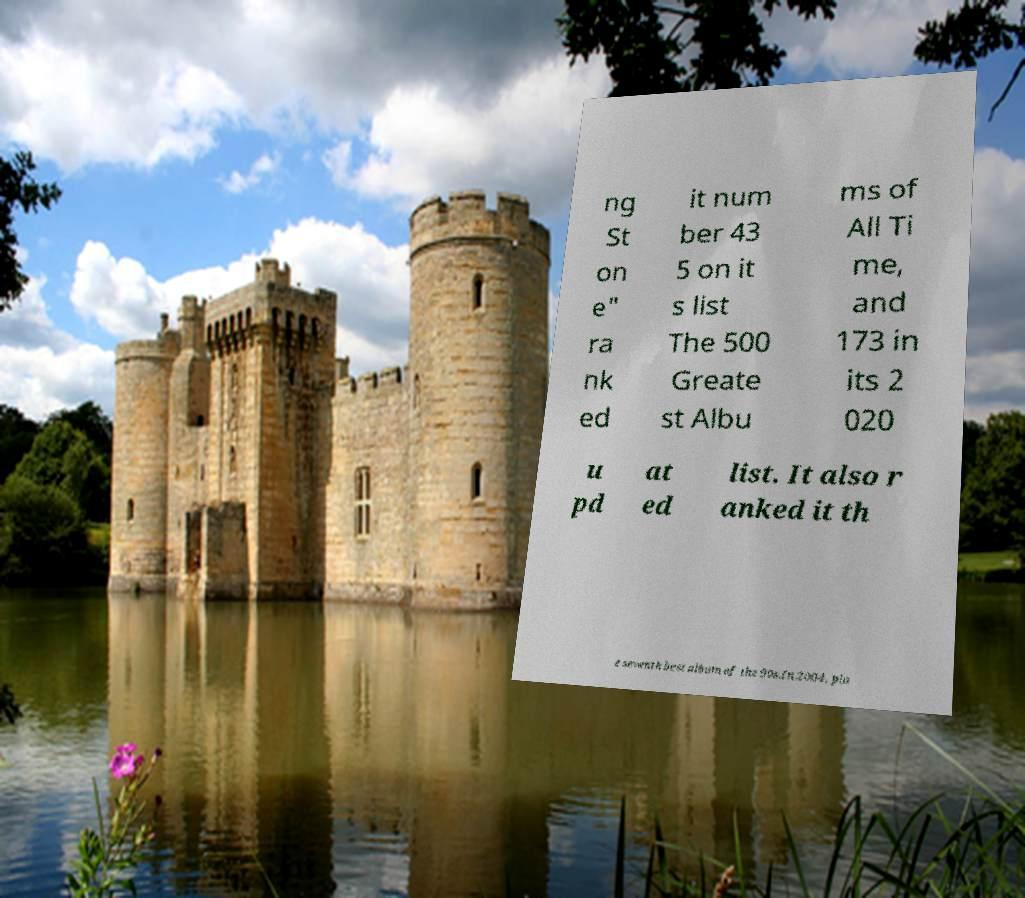Could you assist in decoding the text presented in this image and type it out clearly? ng St on e" ra nk ed it num ber 43 5 on it s list The 500 Greate st Albu ms of All Ti me, and 173 in its 2 020 u pd at ed list. It also r anked it th e seventh best album of the 90s.In 2004, pla 